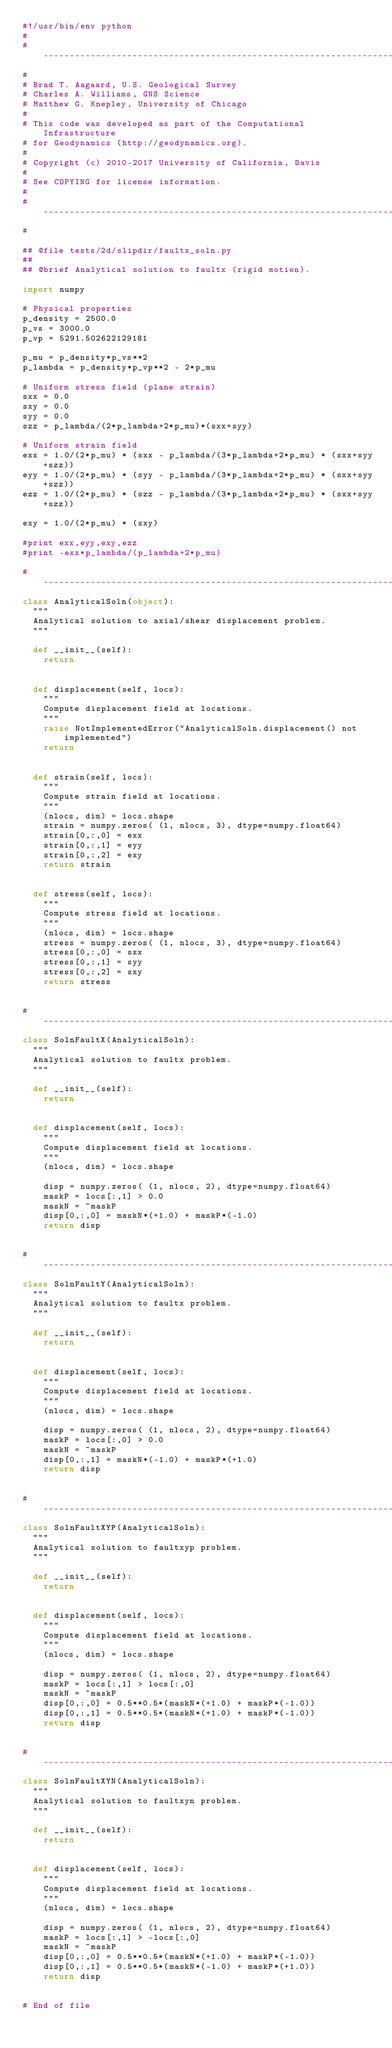Convert code to text. <code><loc_0><loc_0><loc_500><loc_500><_Python_>#!/usr/bin/env python
#
# ----------------------------------------------------------------------
#
# Brad T. Aagaard, U.S. Geological Survey
# Charles A. Williams, GNS Science
# Matthew G. Knepley, University of Chicago
#
# This code was developed as part of the Computational Infrastructure
# for Geodynamics (http://geodynamics.org).
#
# Copyright (c) 2010-2017 University of California, Davis
#
# See COPYING for license information.
#
# ----------------------------------------------------------------------
#

## @file tests/2d/slipdir/faultx_soln.py
##
## @brief Analytical solution to faultx (rigid motion).

import numpy

# Physical properties
p_density = 2500.0
p_vs = 3000.0
p_vp = 5291.502622129181

p_mu = p_density*p_vs**2
p_lambda = p_density*p_vp**2 - 2*p_mu

# Uniform stress field (plane strain)
sxx = 0.0
sxy = 0.0
syy = 0.0
szz = p_lambda/(2*p_lambda+2*p_mu)*(sxx+syy)

# Uniform strain field
exx = 1.0/(2*p_mu) * (sxx - p_lambda/(3*p_lambda+2*p_mu) * (sxx+syy+szz))
eyy = 1.0/(2*p_mu) * (syy - p_lambda/(3*p_lambda+2*p_mu) * (sxx+syy+szz))
ezz = 1.0/(2*p_mu) * (szz - p_lambda/(3*p_lambda+2*p_mu) * (sxx+syy+szz))

exy = 1.0/(2*p_mu) * (sxy)

#print exx,eyy,exy,ezz
#print -exx*p_lambda/(p_lambda+2*p_mu)

# ----------------------------------------------------------------------
class AnalyticalSoln(object):
  """
  Analytical solution to axial/shear displacement problem.
  """

  def __init__(self):
    return


  def displacement(self, locs):
    """
    Compute displacement field at locations.
    """
    raise NotImplementedError("AnalyticalSoln.displacement() not implemented")
    return


  def strain(self, locs):
    """
    Compute strain field at locations.
    """
    (nlocs, dim) = locs.shape
    strain = numpy.zeros( (1, nlocs, 3), dtype=numpy.float64)
    strain[0,:,0] = exx
    strain[0,:,1] = eyy
    strain[0,:,2] = exy
    return strain
  

  def stress(self, locs):
    """
    Compute stress field at locations.
    """
    (nlocs, dim) = locs.shape
    stress = numpy.zeros( (1, nlocs, 3), dtype=numpy.float64)
    stress[0,:,0] = sxx
    stress[0,:,1] = syy
    stress[0,:,2] = sxy
    return stress


# ----------------------------------------------------------------------
class SolnFaultX(AnalyticalSoln):
  """
  Analytical solution to faultx problem.
  """

  def __init__(self):
    return


  def displacement(self, locs):
    """
    Compute displacement field at locations.
    """
    (nlocs, dim) = locs.shape

    disp = numpy.zeros( (1, nlocs, 2), dtype=numpy.float64)
    maskP = locs[:,1] > 0.0
    maskN = ~maskP
    disp[0,:,0] = maskN*(+1.0) + maskP*(-1.0)
    return disp


# ----------------------------------------------------------------------
class SolnFaultY(AnalyticalSoln):
  """
  Analytical solution to faultx problem.
  """

  def __init__(self):
    return


  def displacement(self, locs):
    """
    Compute displacement field at locations.
    """
    (nlocs, dim) = locs.shape

    disp = numpy.zeros( (1, nlocs, 2), dtype=numpy.float64)
    maskP = locs[:,0] > 0.0
    maskN = ~maskP
    disp[0,:,1] = maskN*(-1.0) + maskP*(+1.0)
    return disp


# ----------------------------------------------------------------------
class SolnFaultXYP(AnalyticalSoln):
  """
  Analytical solution to faultxyp problem.
  """

  def __init__(self):
    return


  def displacement(self, locs):
    """
    Compute displacement field at locations.
    """
    (nlocs, dim) = locs.shape

    disp = numpy.zeros( (1, nlocs, 2), dtype=numpy.float64)
    maskP = locs[:,1] > locs[:,0]
    maskN = ~maskP
    disp[0,:,0] = 0.5**0.5*(maskN*(+1.0) + maskP*(-1.0))
    disp[0,:,1] = 0.5**0.5*(maskN*(+1.0) + maskP*(-1.0))
    return disp


# ----------------------------------------------------------------------
class SolnFaultXYN(AnalyticalSoln):
  """
  Analytical solution to faultxyn problem.
  """

  def __init__(self):
    return


  def displacement(self, locs):
    """
    Compute displacement field at locations.
    """
    (nlocs, dim) = locs.shape

    disp = numpy.zeros( (1, nlocs, 2), dtype=numpy.float64)
    maskP = locs[:,1] > -locs[:,0]
    maskN = ~maskP
    disp[0,:,0] = 0.5**0.5*(maskN*(+1.0) + maskP*(-1.0))
    disp[0,:,1] = 0.5**0.5*(maskN*(-1.0) + maskP*(+1.0))
    return disp


# End of file 
</code> 